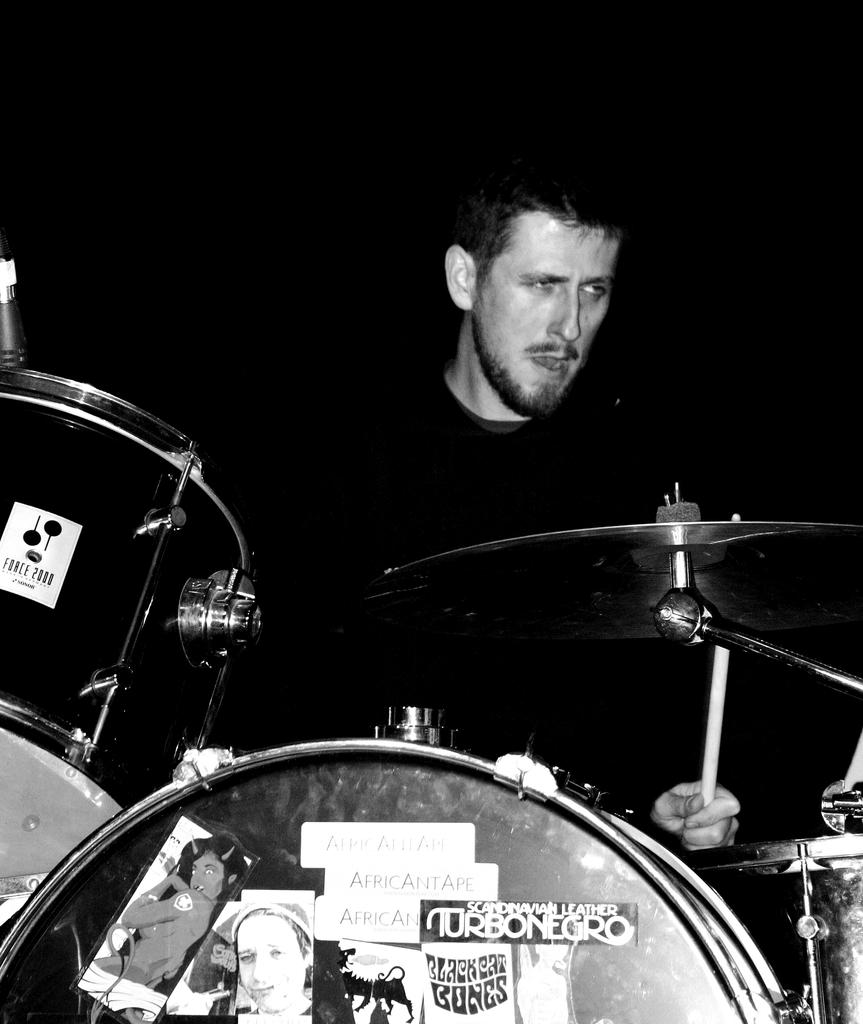What is the main subject in the center of the image? There is a person in the center of the image holding a stick. What else can be seen at the bottom of the image? There are musical instruments at the bottom of the image. What type of appliance is being crushed by the person in the image? There is no appliance present in the image, nor is anyone crushing anything. 